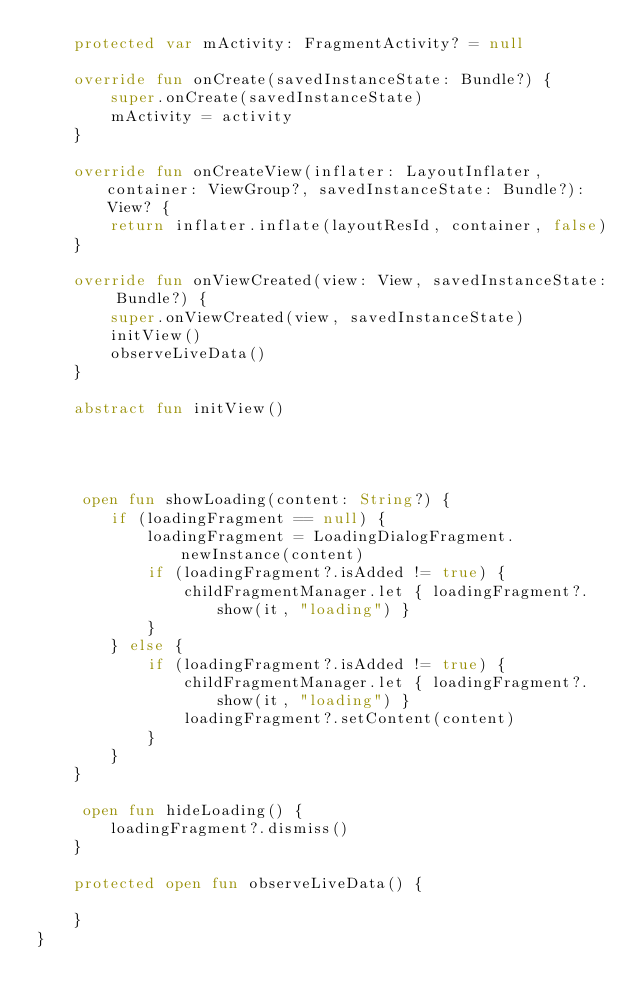Convert code to text. <code><loc_0><loc_0><loc_500><loc_500><_Kotlin_>    protected var mActivity: FragmentActivity? = null

    override fun onCreate(savedInstanceState: Bundle?) {
        super.onCreate(savedInstanceState)
        mActivity = activity
    }

    override fun onCreateView(inflater: LayoutInflater, container: ViewGroup?, savedInstanceState: Bundle?): View? {
        return inflater.inflate(layoutResId, container, false)
    }

    override fun onViewCreated(view: View, savedInstanceState: Bundle?) {
        super.onViewCreated(view, savedInstanceState)
        initView()
        observeLiveData()
    }

    abstract fun initView()




     open fun showLoading(content: String?) {
        if (loadingFragment == null) {
            loadingFragment = LoadingDialogFragment.newInstance(content)
            if (loadingFragment?.isAdded != true) {
                childFragmentManager.let { loadingFragment?.show(it, "loading") }
            }
        } else {
            if (loadingFragment?.isAdded != true) {
                childFragmentManager.let { loadingFragment?.show(it, "loading") }
                loadingFragment?.setContent(content)
            }
        }
    }

     open fun hideLoading() {
        loadingFragment?.dismiss()
    }

    protected open fun observeLiveData() {

    }
}</code> 